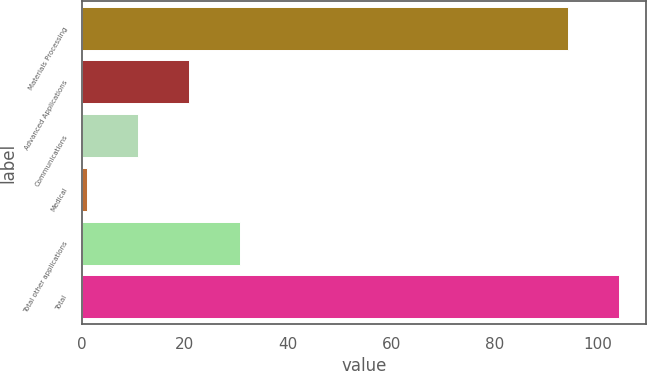<chart> <loc_0><loc_0><loc_500><loc_500><bar_chart><fcel>Materials Processing<fcel>Advanced Applications<fcel>Communications<fcel>Medical<fcel>Total other applications<fcel>Total<nl><fcel>94.2<fcel>20.8<fcel>10.9<fcel>1<fcel>30.7<fcel>104.1<nl></chart> 